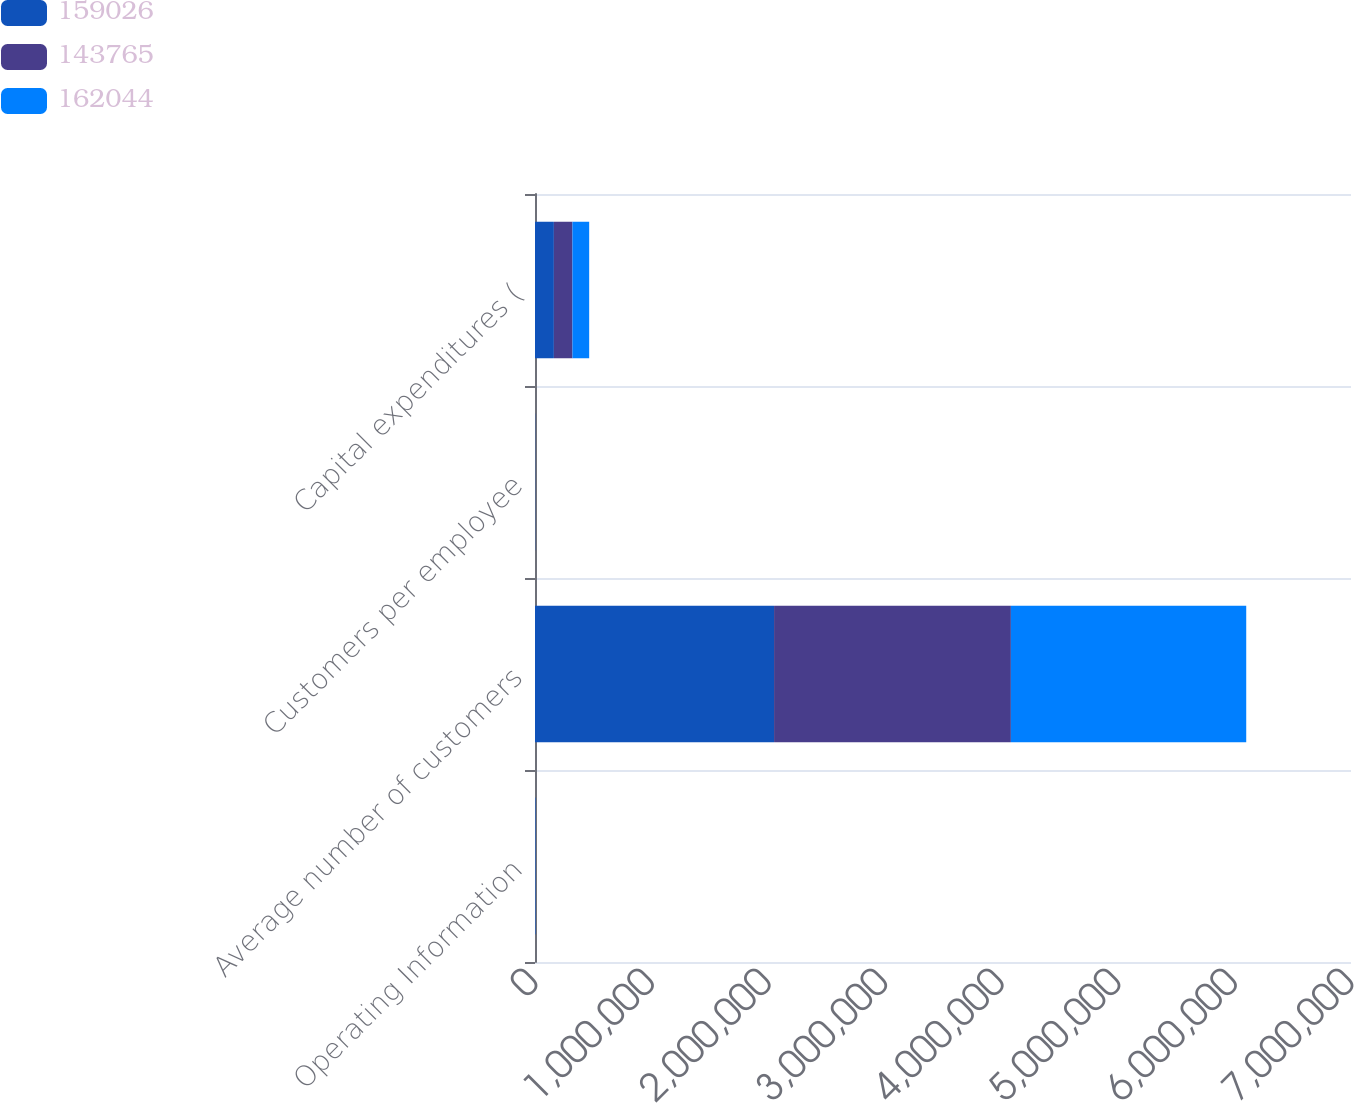Convert chart. <chart><loc_0><loc_0><loc_500><loc_500><stacked_bar_chart><ecel><fcel>Operating Information<fcel>Average number of customers<fcel>Customers per employee<fcel>Capital expenditures (<nl><fcel>159026<fcel>2007<fcel>2.05077e+06<fcel>732<fcel>162044<nl><fcel>143765<fcel>2006<fcel>2.03155e+06<fcel>713<fcel>159026<nl><fcel>162044<fcel>2005<fcel>2.0189e+06<fcel>689<fcel>143765<nl></chart> 